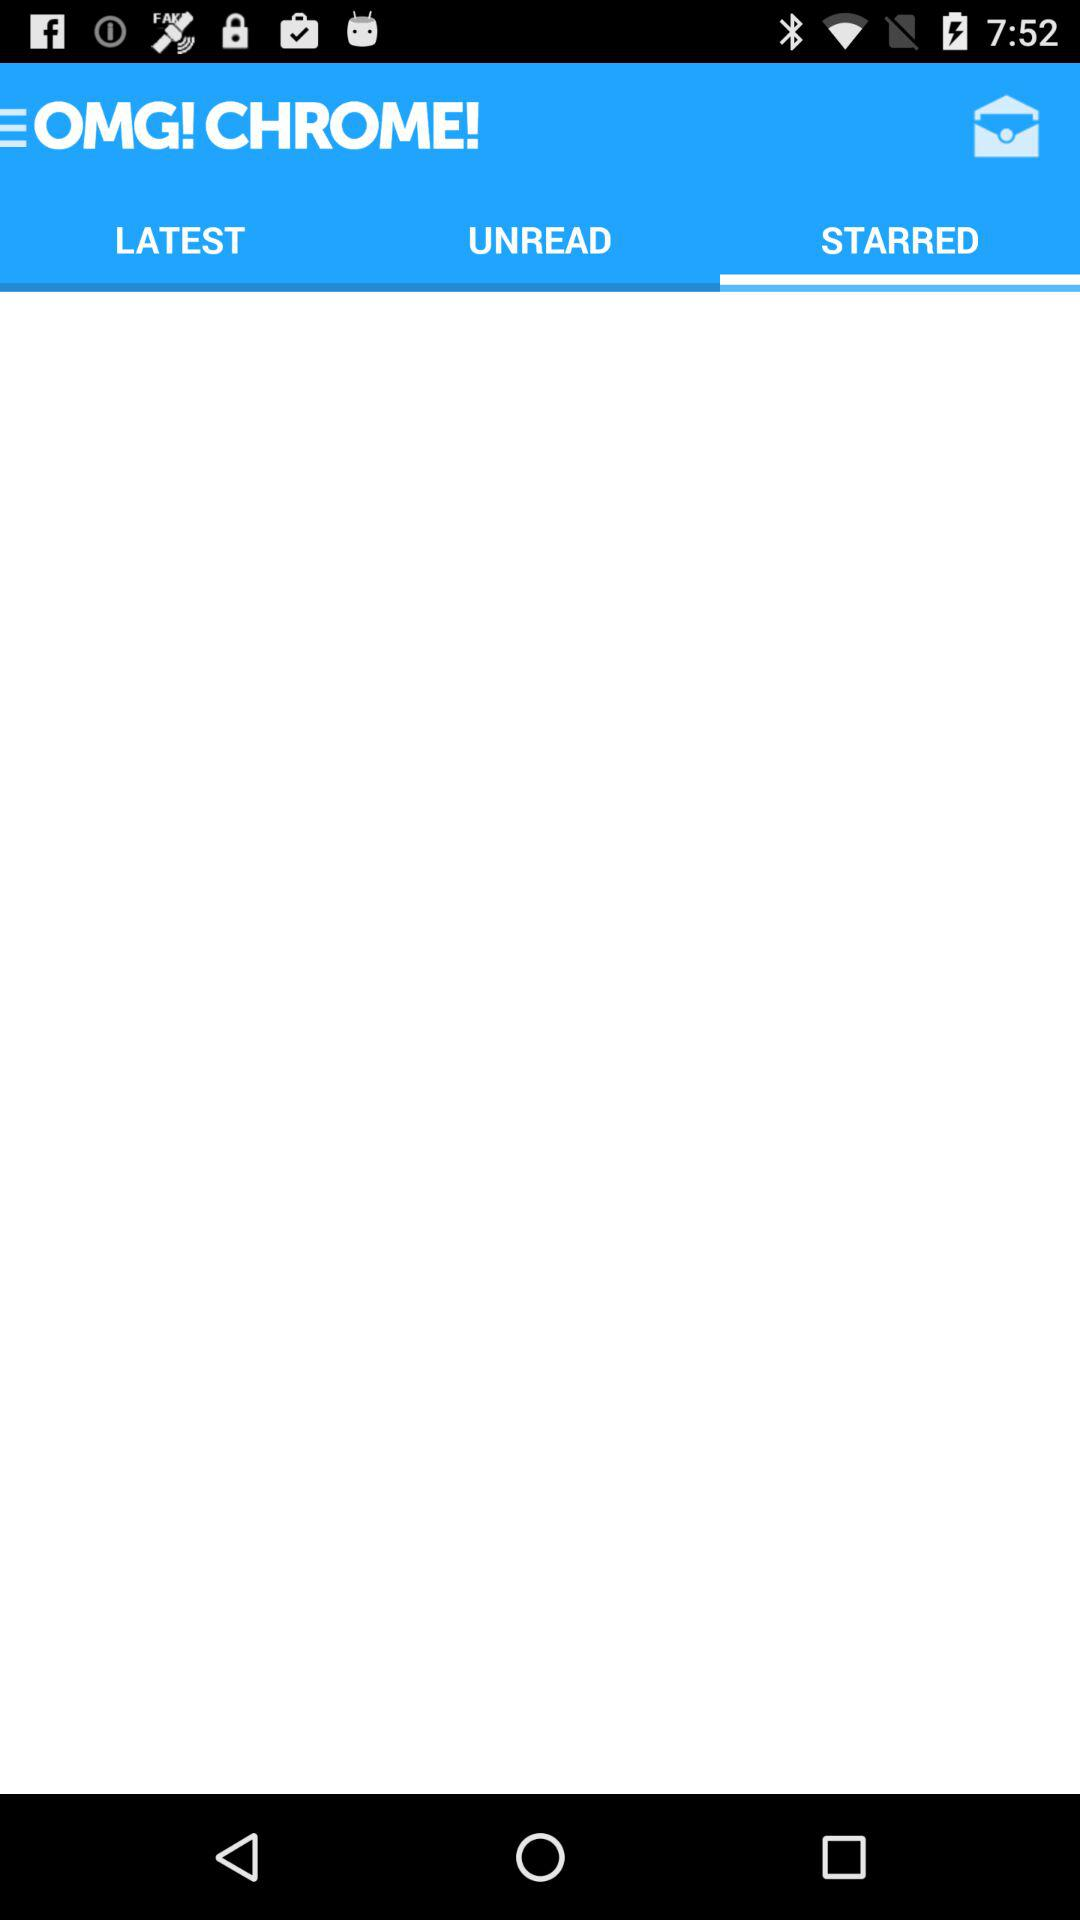What is the application name? The application name is "OMG! CHROME!". 